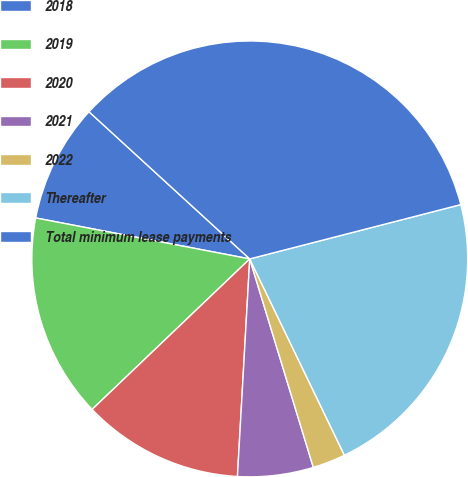Convert chart. <chart><loc_0><loc_0><loc_500><loc_500><pie_chart><fcel>2018<fcel>2019<fcel>2020<fcel>2021<fcel>2022<fcel>Thereafter<fcel>Total minimum lease payments<nl><fcel>8.79%<fcel>15.14%<fcel>11.97%<fcel>5.61%<fcel>2.44%<fcel>21.86%<fcel>34.19%<nl></chart> 